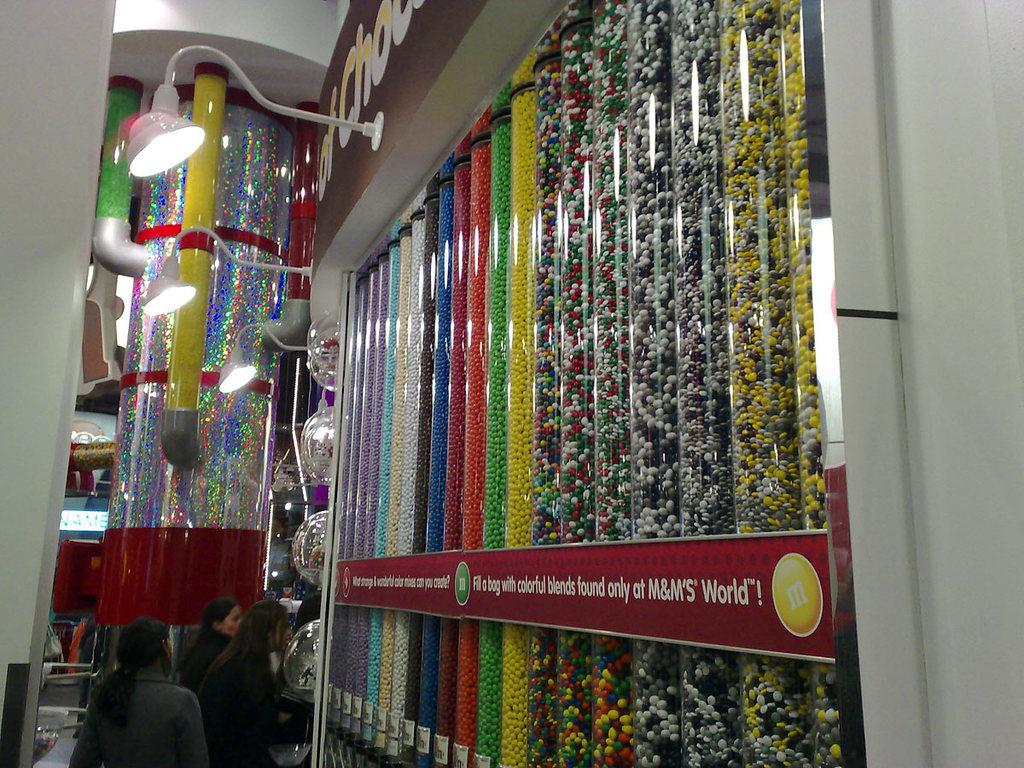<image>
Share a concise interpretation of the image provided. Large containers of candy have a red sign on the instructing to fill a bag. 